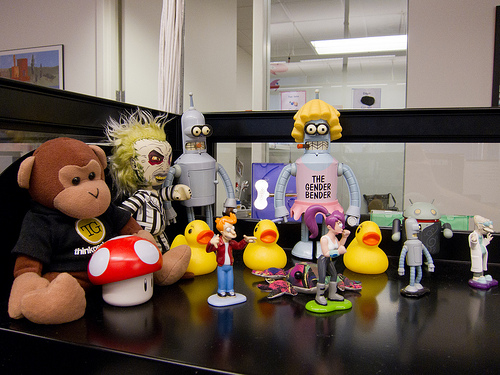<image>
Can you confirm if the window is next to the wall? Yes. The window is positioned adjacent to the wall, located nearby in the same general area. 